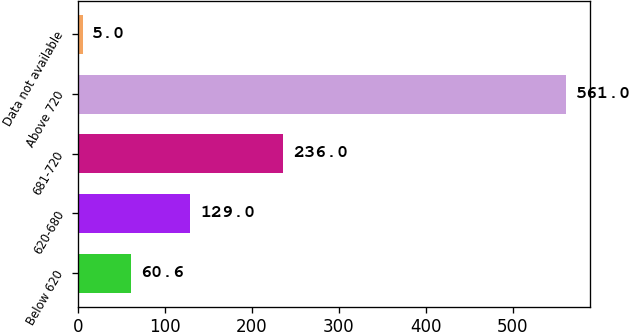Convert chart to OTSL. <chart><loc_0><loc_0><loc_500><loc_500><bar_chart><fcel>Below 620<fcel>620-680<fcel>681-720<fcel>Above 720<fcel>Data not available<nl><fcel>60.6<fcel>129<fcel>236<fcel>561<fcel>5<nl></chart> 